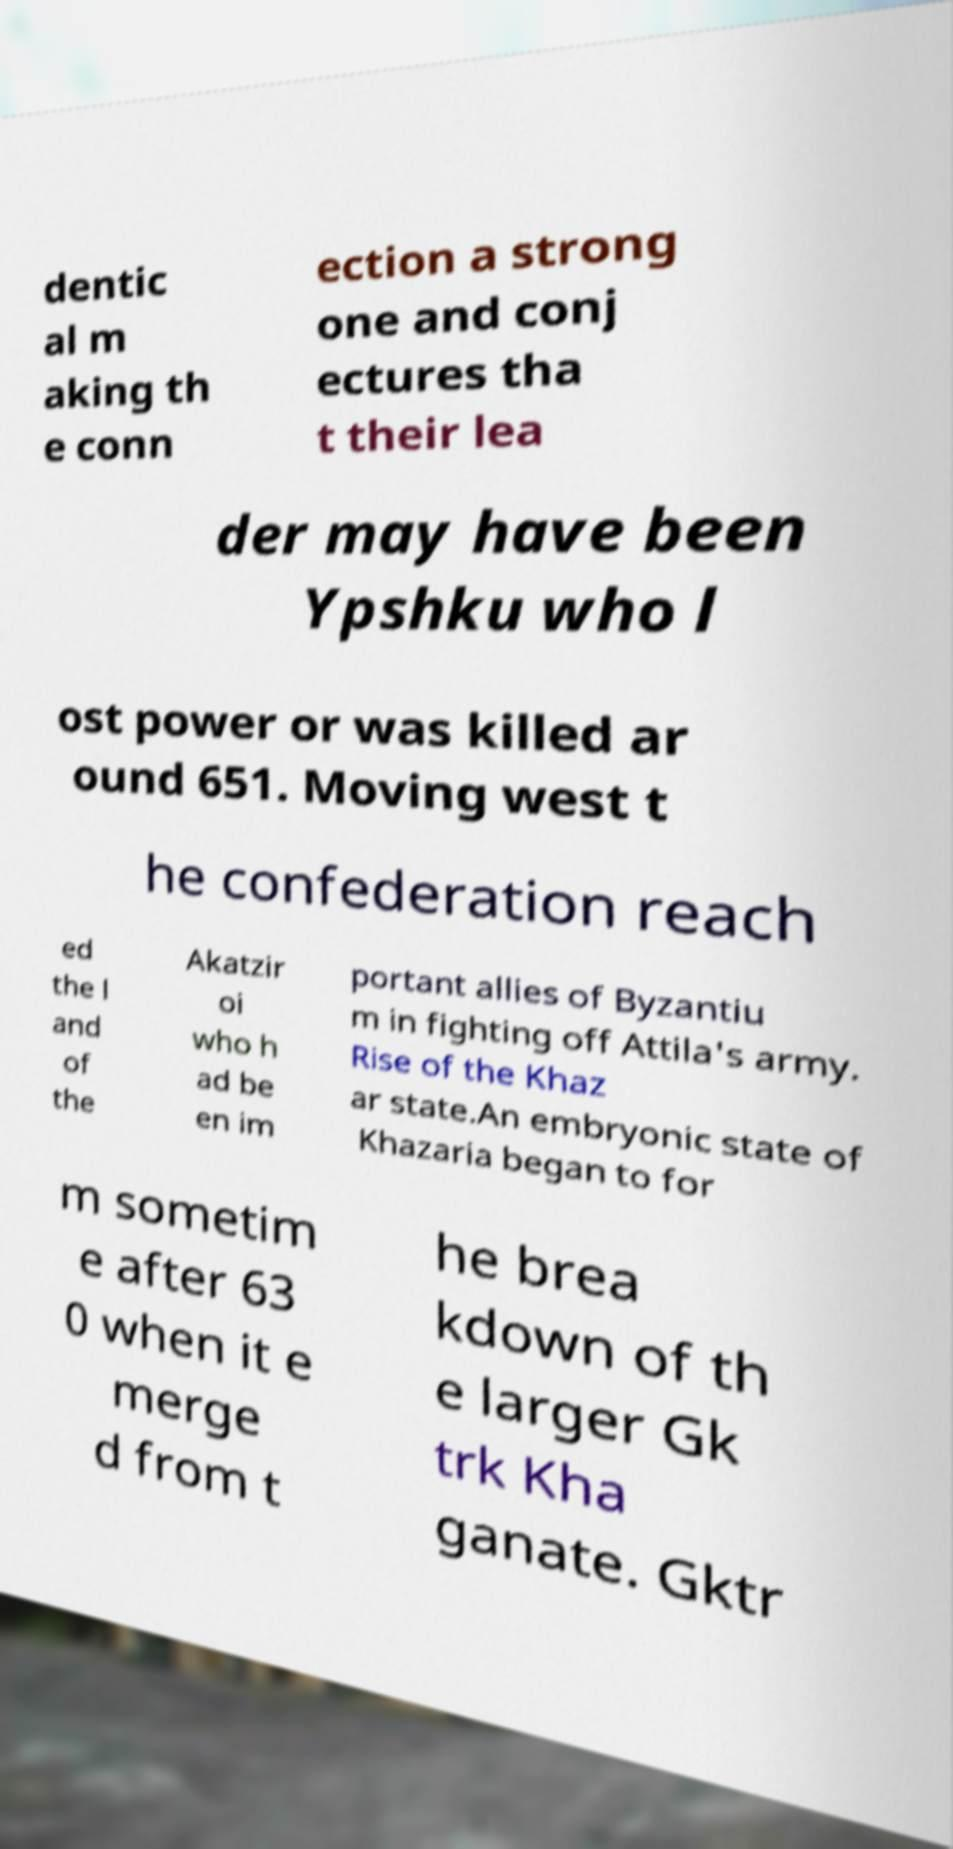Can you accurately transcribe the text from the provided image for me? dentic al m aking th e conn ection a strong one and conj ectures tha t their lea der may have been Ypshku who l ost power or was killed ar ound 651. Moving west t he confederation reach ed the l and of the Akatzir oi who h ad be en im portant allies of Byzantiu m in fighting off Attila's army. Rise of the Khaz ar state.An embryonic state of Khazaria began to for m sometim e after 63 0 when it e merge d from t he brea kdown of th e larger Gk trk Kha ganate. Gktr 